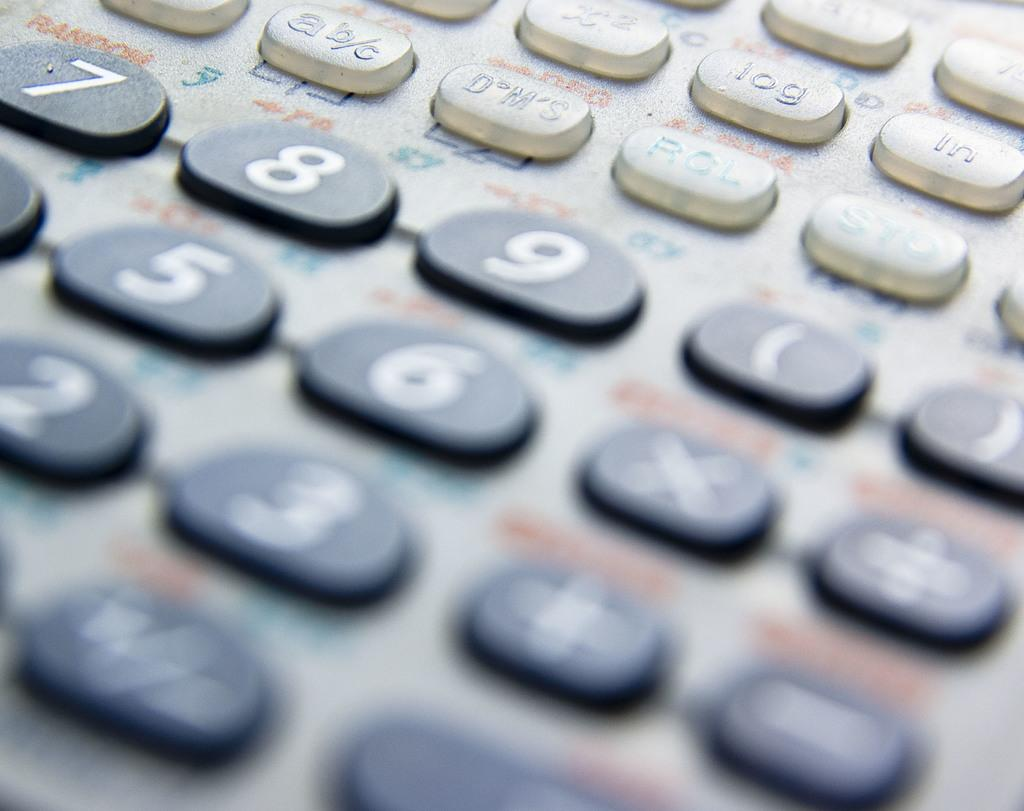<image>
Give a short and clear explanation of the subsequent image. A closeup of a keypad with the number 9 in the middle. 